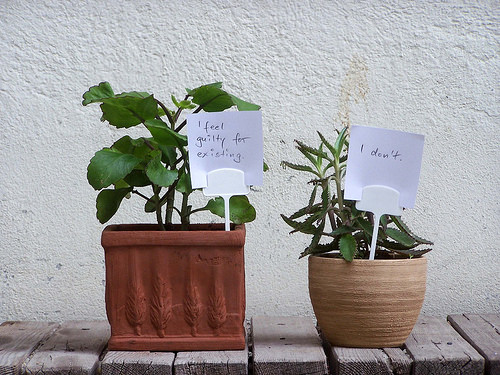<image>
Can you confirm if the plant is next to the wall? Yes. The plant is positioned adjacent to the wall, located nearby in the same general area. Is there a sign in the potted plant? No. The sign is not contained within the potted plant. These objects have a different spatial relationship. Is there a plant in the pot? No. The plant is not contained within the pot. These objects have a different spatial relationship. 